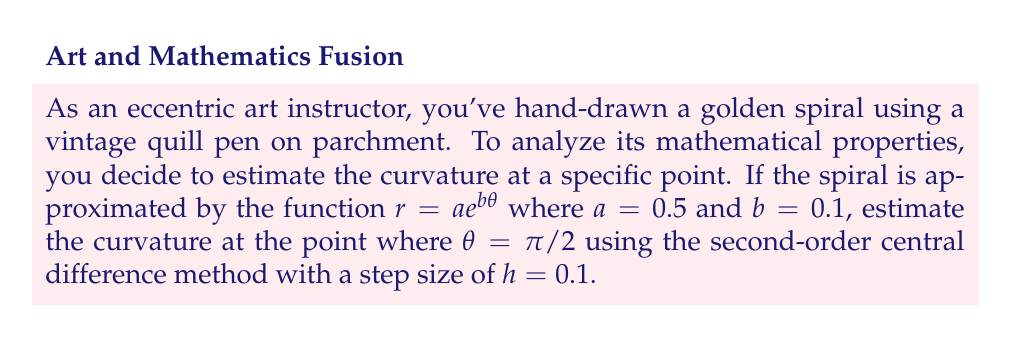Can you answer this question? To estimate the curvature of the spiral, we'll follow these steps:

1) The curvature of a polar curve is given by:

   $$\kappa = \frac{|r^2 + 2(r')^2 - rr''|}{(r^2 + (r')^2)^{3/2}}$$

2) We need to calculate $r$, $r'$, and $r''$ at $\theta = \pi/2$.

3) For $r$:
   $$r = 0.5 e^{0.1(\pi/2)} \approx 0.5934$$

4) For $r'$, we use the central difference formula:
   $$r' \approx \frac{r(\theta + h) - r(\theta - h)}{2h}$$
   
   $$r' \approx \frac{0.5e^{0.1(\pi/2 + 0.1)} - 0.5e^{0.1(\pi/2 - 0.1)}}{2(0.1)} \approx 0.05952$$

5) For $r''$, we use the second-order central difference formula:
   $$r'' \approx \frac{r(\theta + h) - 2r(\theta) + r(\theta - h)}{h^2}$$
   
   $$r'' \approx \frac{0.5e^{0.1(\pi/2 + 0.1)} - 2(0.5e^{0.1(\pi/2)}) + 0.5e^{0.1(\pi/2 - 0.1)}}{0.1^2} \approx 0.00601$$

6) Now, we can substitute these values into the curvature formula:

   $$\kappa \approx \frac{|0.5934^2 + 2(0.05952)^2 - 0.5934(0.00601)|}{(0.5934^2 + 0.05952^2)^{3/2}}$$

7) Calculating this gives us:

   $$\kappa \approx 1.6833$$

Thus, the estimated curvature at $\theta = \pi/2$ is approximately 1.6833.
Answer: $\kappa \approx 1.6833$ 